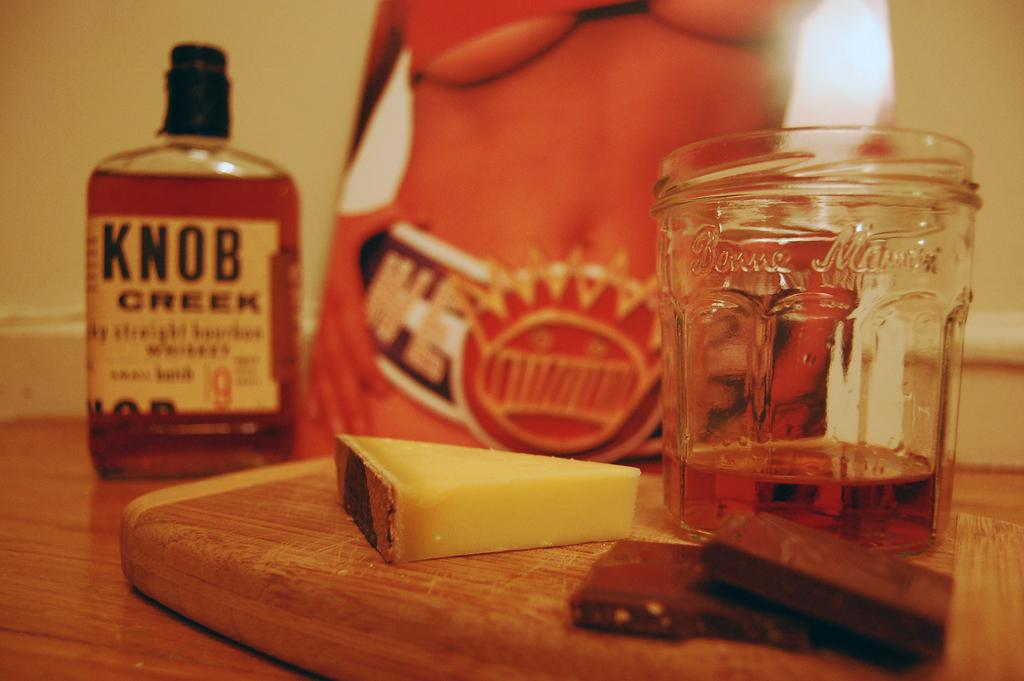<image>
Render a clear and concise summary of the photo. a bottle has the word knob on it 